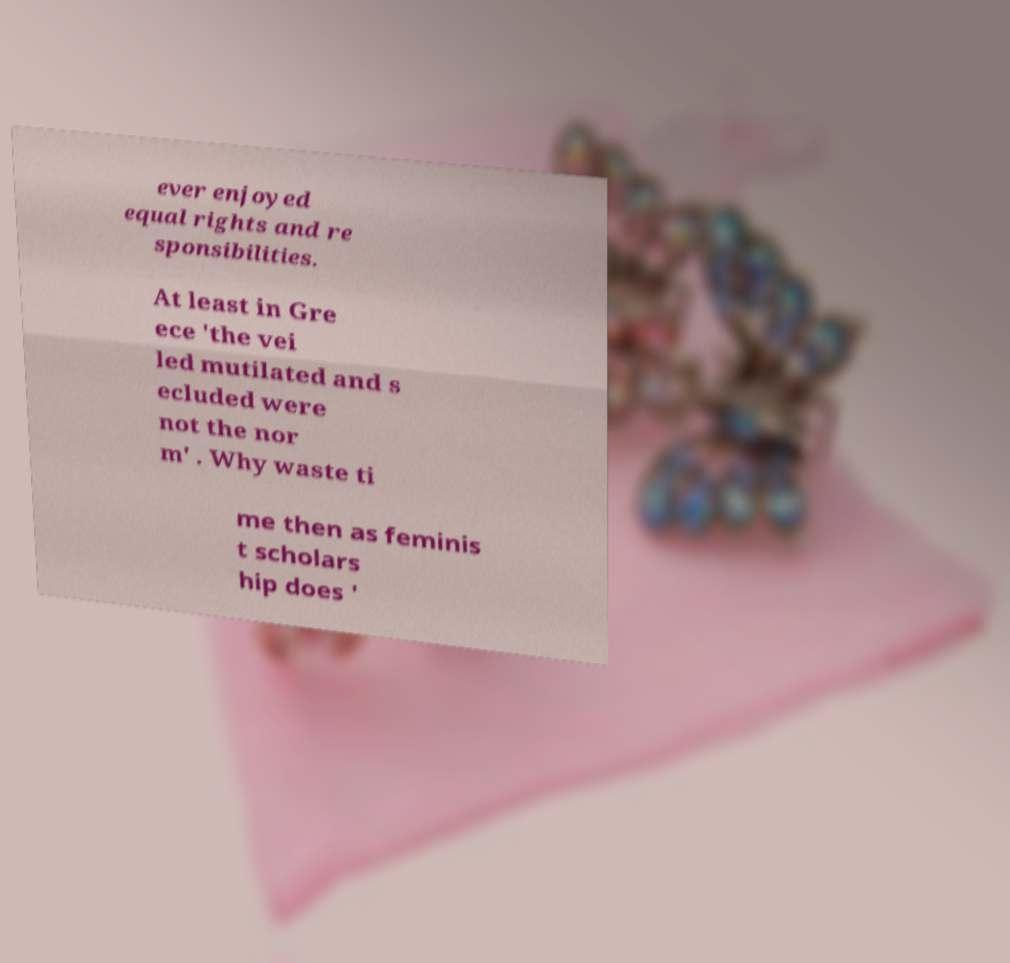Please identify and transcribe the text found in this image. ever enjoyed equal rights and re sponsibilities. At least in Gre ece 'the vei led mutilated and s ecluded were not the nor m' . Why waste ti me then as feminis t scholars hip does ' 